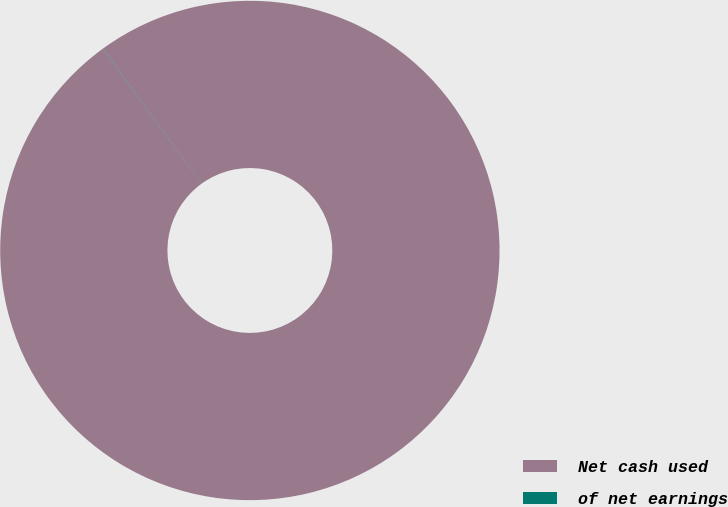Convert chart. <chart><loc_0><loc_0><loc_500><loc_500><pie_chart><fcel>Net cash used<fcel>of net earnings<nl><fcel>99.98%<fcel>0.02%<nl></chart> 